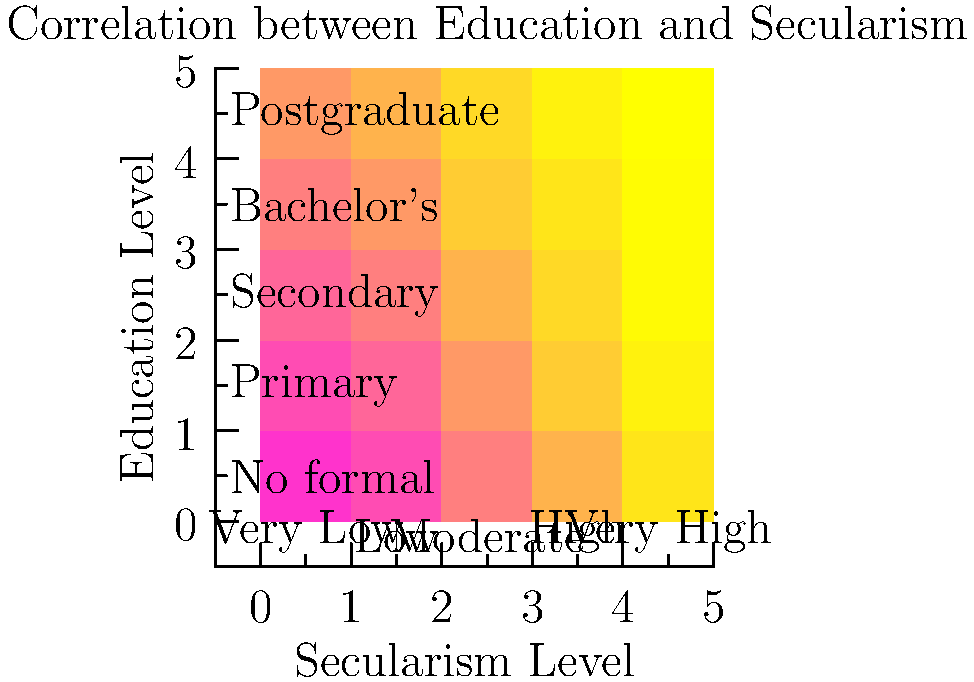Based on the heat map showing the correlation between education levels and secularism, which education level demonstrates the strongest association with very high levels of secularism? To answer this question, we need to analyze the heat map systematically:

1. The x-axis represents the secularism level, ranging from "Very Low" to "Very High".
2. The y-axis represents the education level, from "No formal" education to "Postgraduate".
3. The intensity of the color in each cell indicates the strength of the correlation, with darker colors representing stronger correlations.

Let's examine the "Very High" secularism column:

1. No formal education: Lightest color, indicating the weakest correlation.
2. Primary education: Slightly darker, but still a weak correlation.
3. Secondary education: Darker, showing a moderate correlation.
4. Bachelor's degree: Even darker, indicating a strong correlation.
5. Postgraduate degree: Darkest color, representing the strongest correlation.

The heat map clearly shows that as the education level increases, the correlation with very high levels of secularism also increases. The darkest cell in the "Very High" secularism column corresponds to the "Postgraduate" education level.
Answer: Postgraduate 